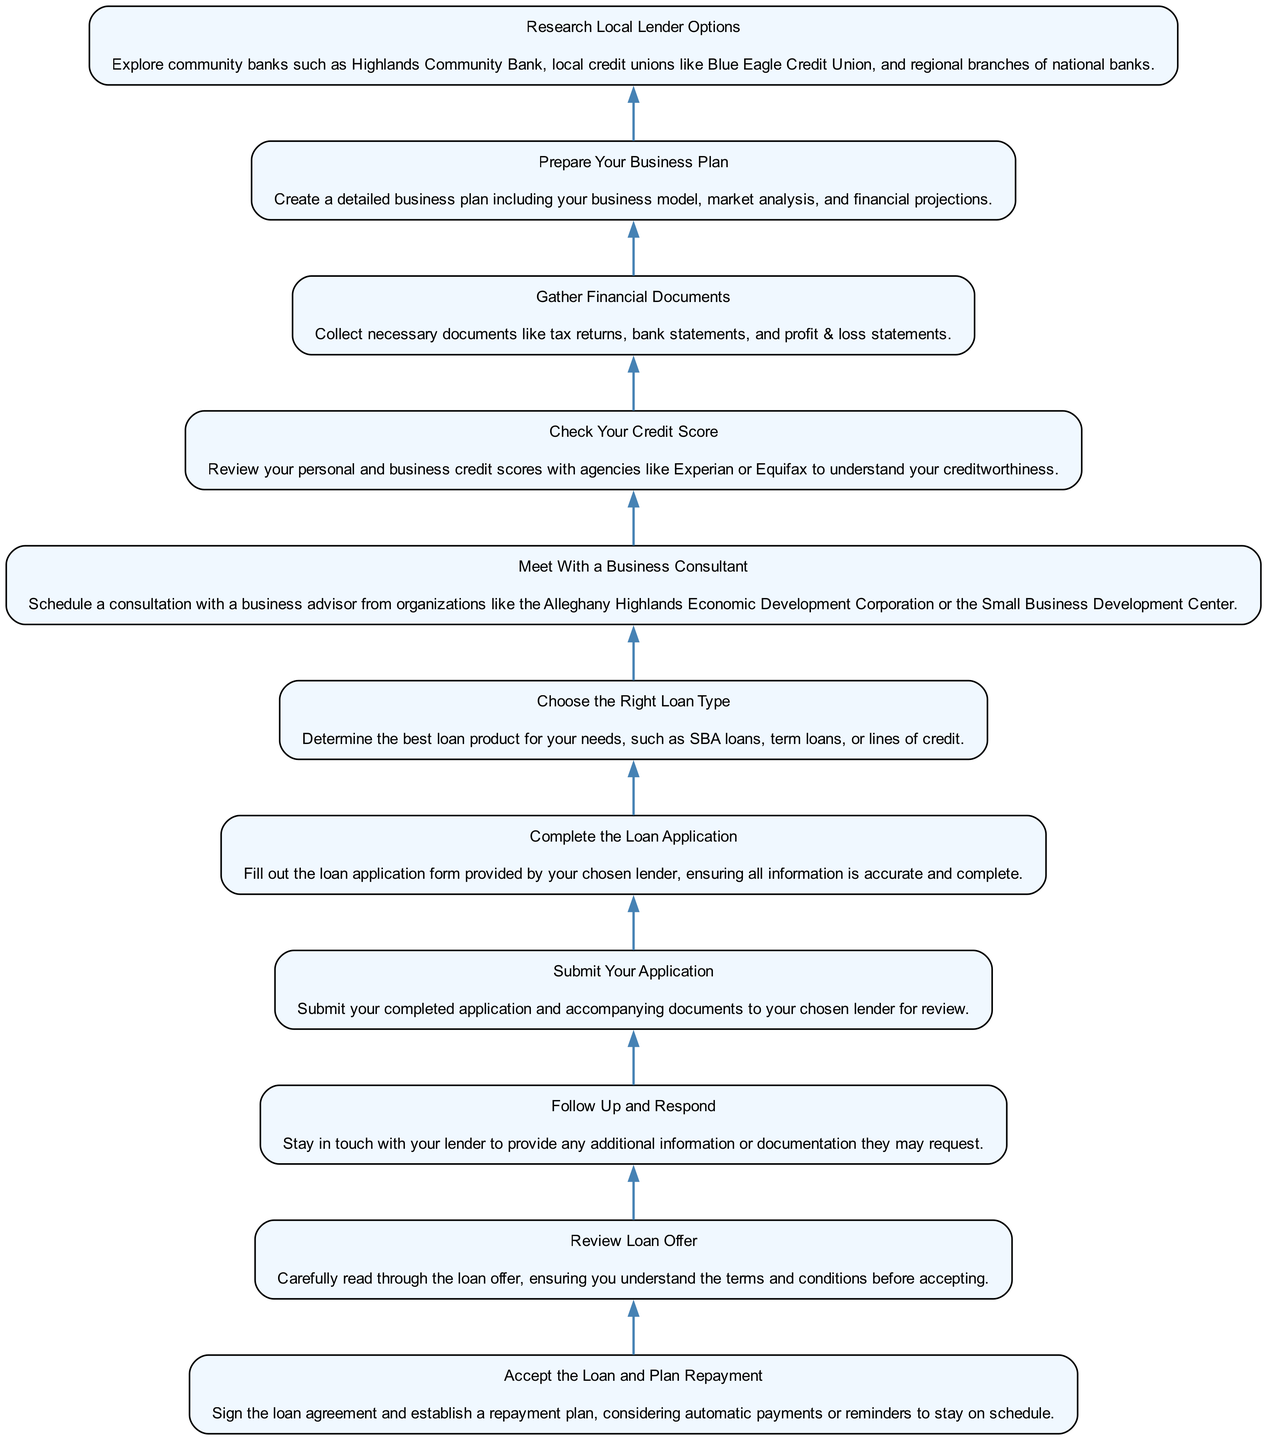What is the first step in applying for a small business loan? The diagram begins with the first step at the bottom, which is "Research Local Lender Options." It outlines the initial action required before moving to the subsequent steps.
Answer: Research Local Lender Options How many steps are in the loan application process? By counting the different elements listed in the diagram, there are eleven steps involved in the process from start to finish.
Answer: Eleven What should you do after submitting your application? The following step immediately after submitting your application is to "Follow Up and Respond," indicating the importance of communication with the lender.
Answer: Follow Up and Respond What is the final action in the loan application process? The final step depicted at the top of the diagram is "Accept the Loan and Plan Repayment," which signifies the completion of the application with an agreement.
Answer: Accept the Loan and Plan Repayment What is required after meeting with a business consultant? The next logical step after meeting with a business consultant is to "Choose the Right Loan Type," indicating that insights from the consultant help in making an informed decision about the type of loan to pursue.
Answer: Choose the Right Loan Type What is the relationship between checking your credit score and gathering financial documents? "Check Your Credit Score" precedes "Gather Financial Documents," suggesting that understanding your creditworthiness is essential before compiling your financial documentation for the loan application.
Answer: Check Your Credit Score precedes Gather Financial Documents What category does 'Complete the Loan Application' fall under in this process? "Complete the Loan Application" is categorized as a critical step in the application process, directly indicating that it's essential to fill out the application to proceed with loan consideration.
Answer: Critical step Which step involves understanding the loan's terms? In the diagram, the step where you review the loan offer to comprehend its terms and conditions is labeled "Review Loan Offer," indicating a crucial phase before acceptance.
Answer: Review Loan Offer What type of organizations should you consult with for business advice? The diagram recommends consulting with organizations like the Alleghany Highlands Economic Development Corporation or the Small Business Development Center, highlighting local resources for guidance.
Answer: Local organizations 